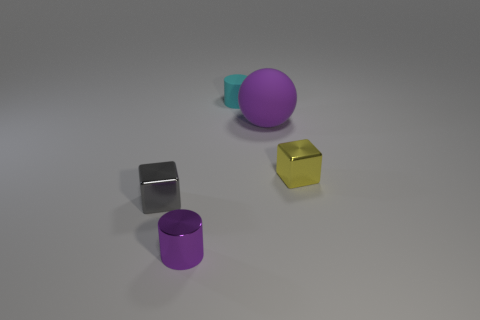What might be the purpose of these objects? These objects could serve multiple purposes. They may be part of a design or color study, used in a 3D modeling software to demonstrate shapes and materials, or they might be part of a visual art composition, exploring form and color interaction. Could they be used for educational purposes? Absolutely, they are ideal for educational settings, such as teaching geometry, spatial awareness, or color theory. Their distinct shapes and colors can help in distinguishing between different geometric forms and understanding the basics of 3D representation. 